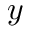<formula> <loc_0><loc_0><loc_500><loc_500>y</formula> 